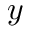<formula> <loc_0><loc_0><loc_500><loc_500>y</formula> 